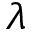<formula> <loc_0><loc_0><loc_500><loc_500>\lambda</formula> 